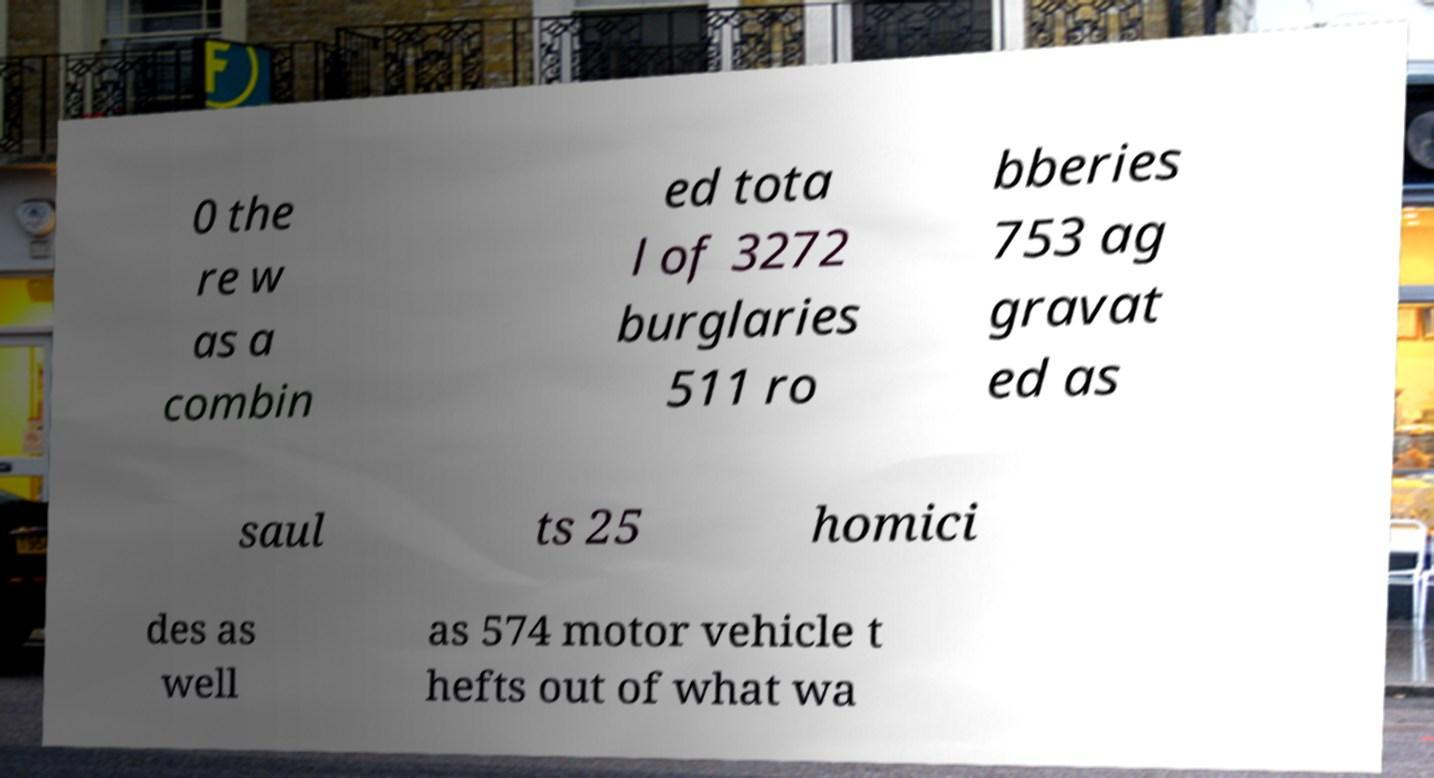There's text embedded in this image that I need extracted. Can you transcribe it verbatim? 0 the re w as a combin ed tota l of 3272 burglaries 511 ro bberies 753 ag gravat ed as saul ts 25 homici des as well as 574 motor vehicle t hefts out of what wa 